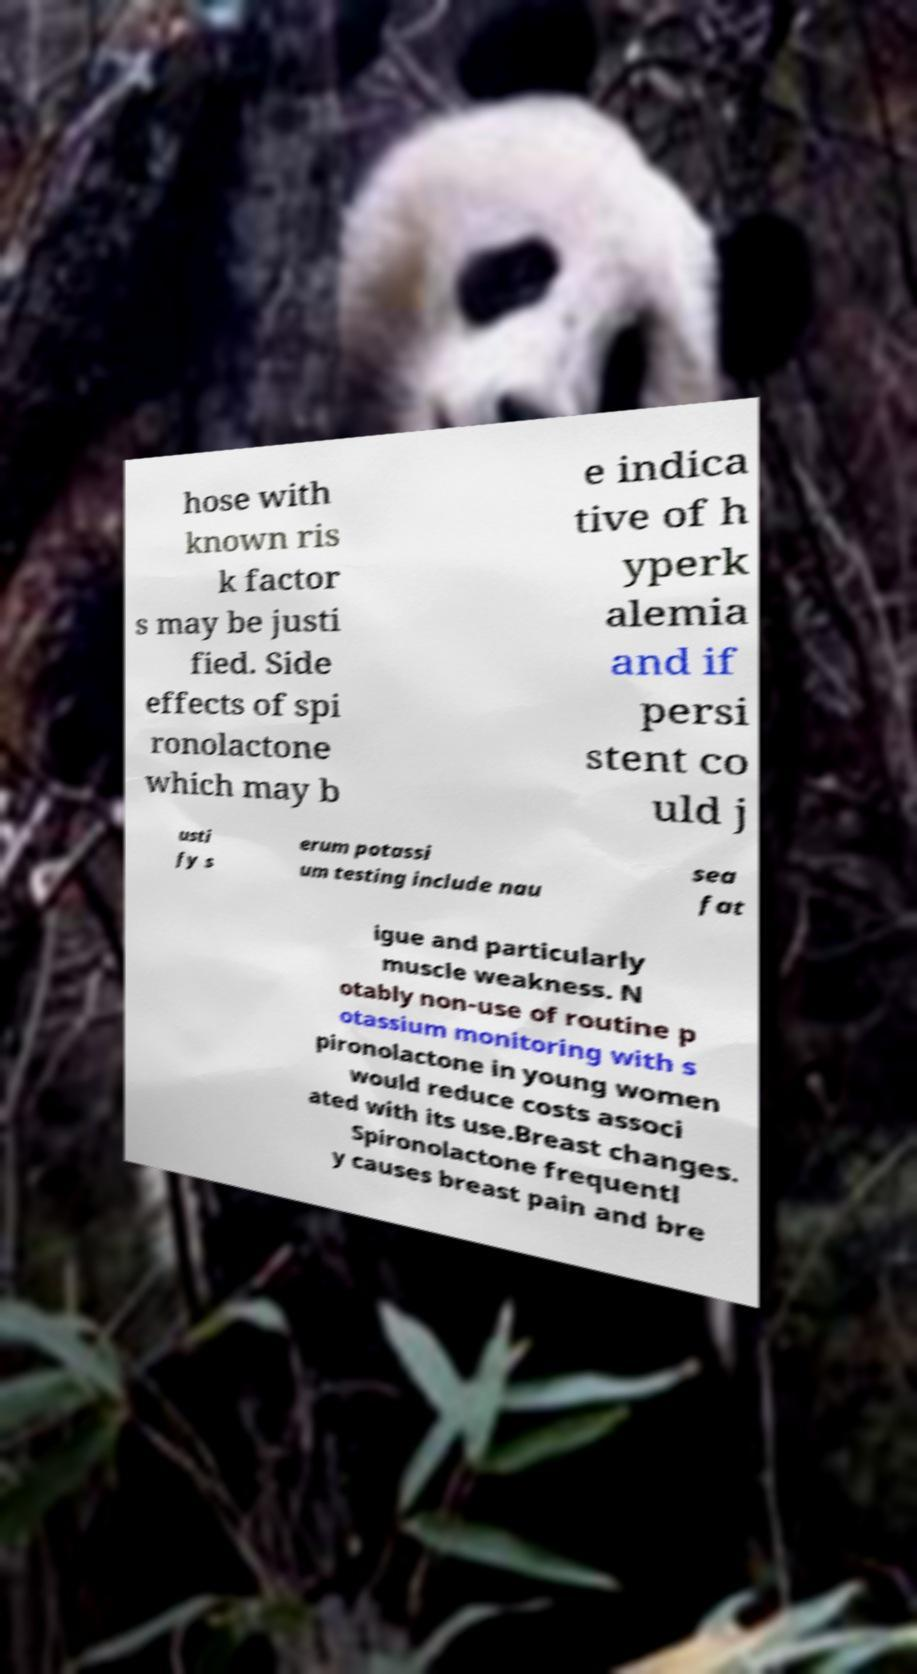Could you extract and type out the text from this image? hose with known ris k factor s may be justi fied. Side effects of spi ronolactone which may b e indica tive of h yperk alemia and if persi stent co uld j usti fy s erum potassi um testing include nau sea fat igue and particularly muscle weakness. N otably non-use of routine p otassium monitoring with s pironolactone in young women would reduce costs associ ated with its use.Breast changes. Spironolactone frequentl y causes breast pain and bre 